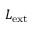<formula> <loc_0><loc_0><loc_500><loc_500>L _ { e x t }</formula> 